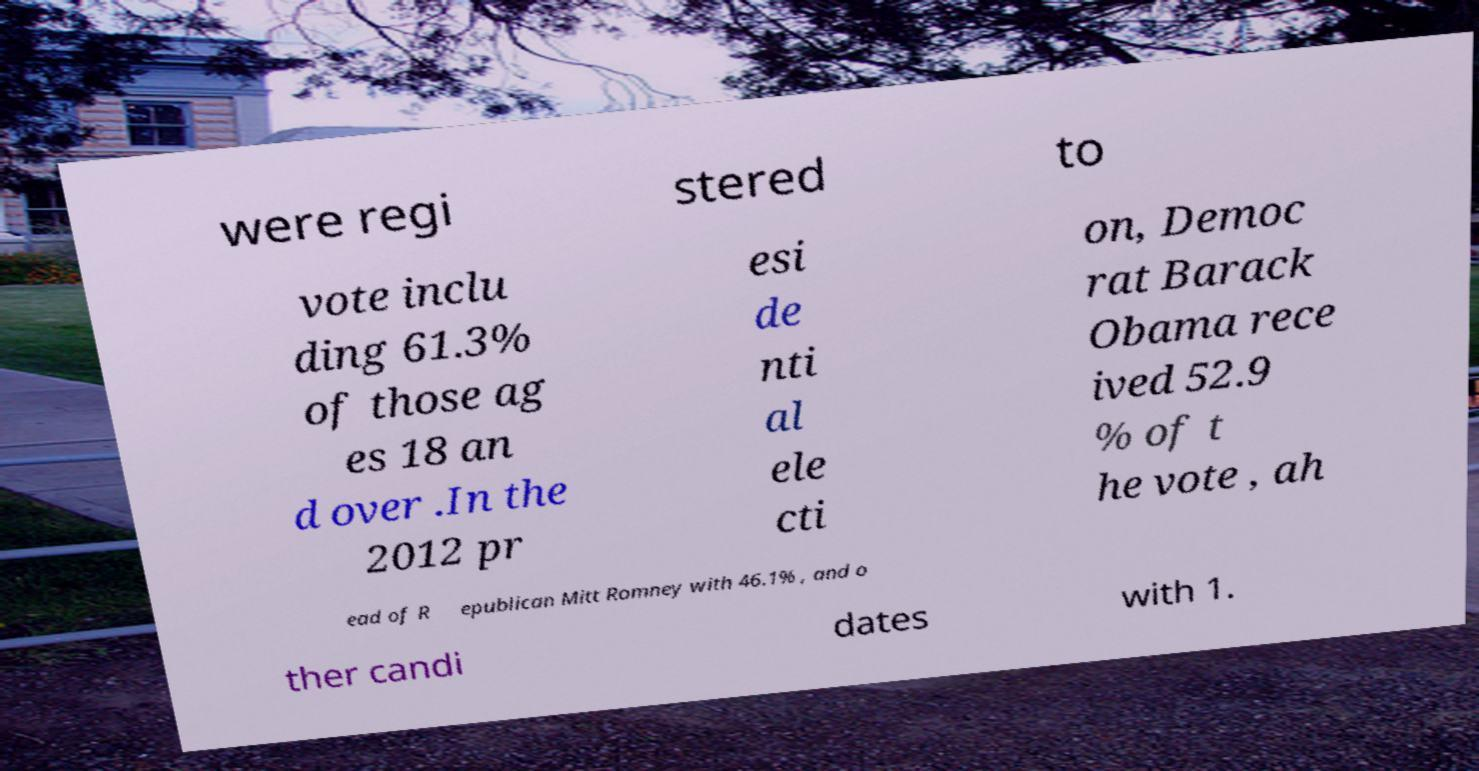Can you read and provide the text displayed in the image?This photo seems to have some interesting text. Can you extract and type it out for me? were regi stered to vote inclu ding 61.3% of those ag es 18 an d over .In the 2012 pr esi de nti al ele cti on, Democ rat Barack Obama rece ived 52.9 % of t he vote , ah ead of R epublican Mitt Romney with 46.1% , and o ther candi dates with 1. 